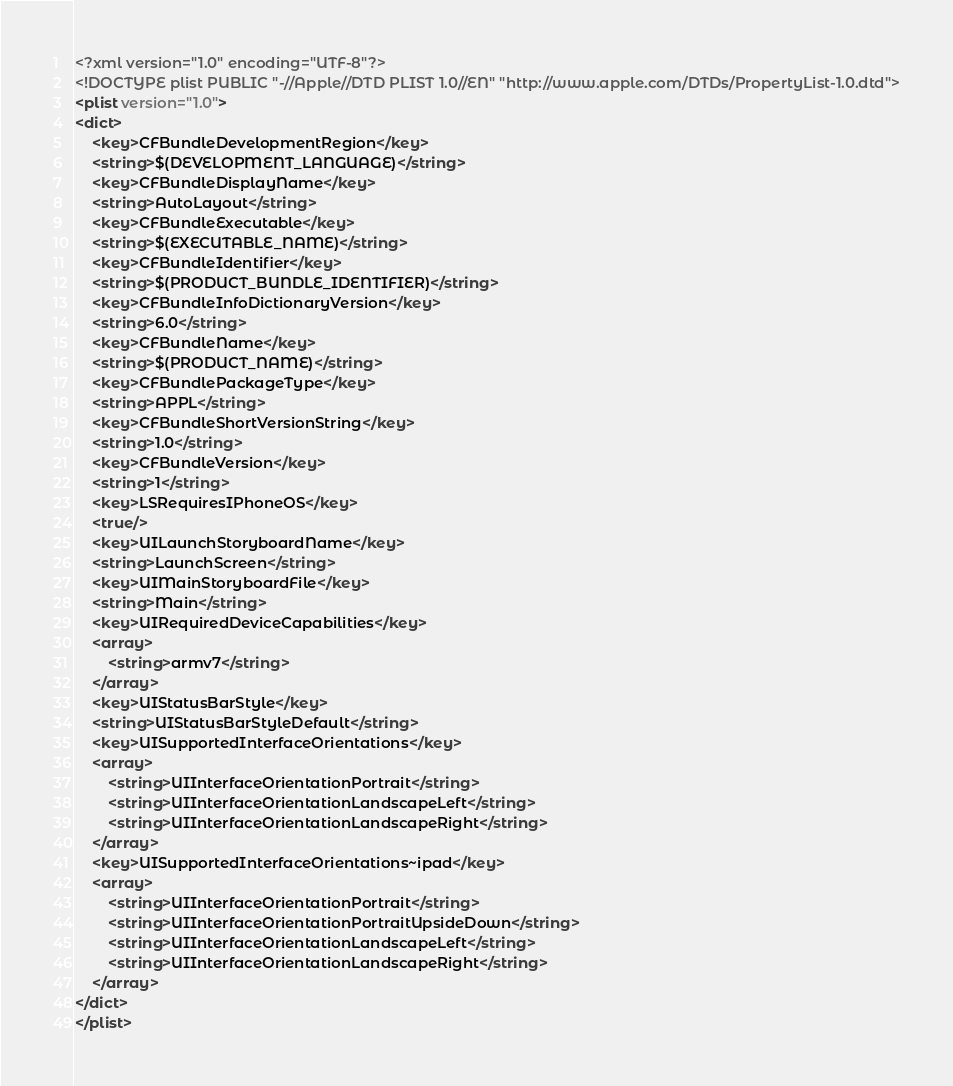Convert code to text. <code><loc_0><loc_0><loc_500><loc_500><_XML_><?xml version="1.0" encoding="UTF-8"?>
<!DOCTYPE plist PUBLIC "-//Apple//DTD PLIST 1.0//EN" "http://www.apple.com/DTDs/PropertyList-1.0.dtd">
<plist version="1.0">
<dict>
	<key>CFBundleDevelopmentRegion</key>
	<string>$(DEVELOPMENT_LANGUAGE)</string>
	<key>CFBundleDisplayName</key>
	<string>AutoLayout</string>
	<key>CFBundleExecutable</key>
	<string>$(EXECUTABLE_NAME)</string>
	<key>CFBundleIdentifier</key>
	<string>$(PRODUCT_BUNDLE_IDENTIFIER)</string>
	<key>CFBundleInfoDictionaryVersion</key>
	<string>6.0</string>
	<key>CFBundleName</key>
	<string>$(PRODUCT_NAME)</string>
	<key>CFBundlePackageType</key>
	<string>APPL</string>
	<key>CFBundleShortVersionString</key>
	<string>1.0</string>
	<key>CFBundleVersion</key>
	<string>1</string>
	<key>LSRequiresIPhoneOS</key>
	<true/>
	<key>UILaunchStoryboardName</key>
	<string>LaunchScreen</string>
	<key>UIMainStoryboardFile</key>
	<string>Main</string>
	<key>UIRequiredDeviceCapabilities</key>
	<array>
		<string>armv7</string>
	</array>
	<key>UIStatusBarStyle</key>
	<string>UIStatusBarStyleDefault</string>
	<key>UISupportedInterfaceOrientations</key>
	<array>
		<string>UIInterfaceOrientationPortrait</string>
		<string>UIInterfaceOrientationLandscapeLeft</string>
		<string>UIInterfaceOrientationLandscapeRight</string>
	</array>
	<key>UISupportedInterfaceOrientations~ipad</key>
	<array>
		<string>UIInterfaceOrientationPortrait</string>
		<string>UIInterfaceOrientationPortraitUpsideDown</string>
		<string>UIInterfaceOrientationLandscapeLeft</string>
		<string>UIInterfaceOrientationLandscapeRight</string>
	</array>
</dict>
</plist>
</code> 